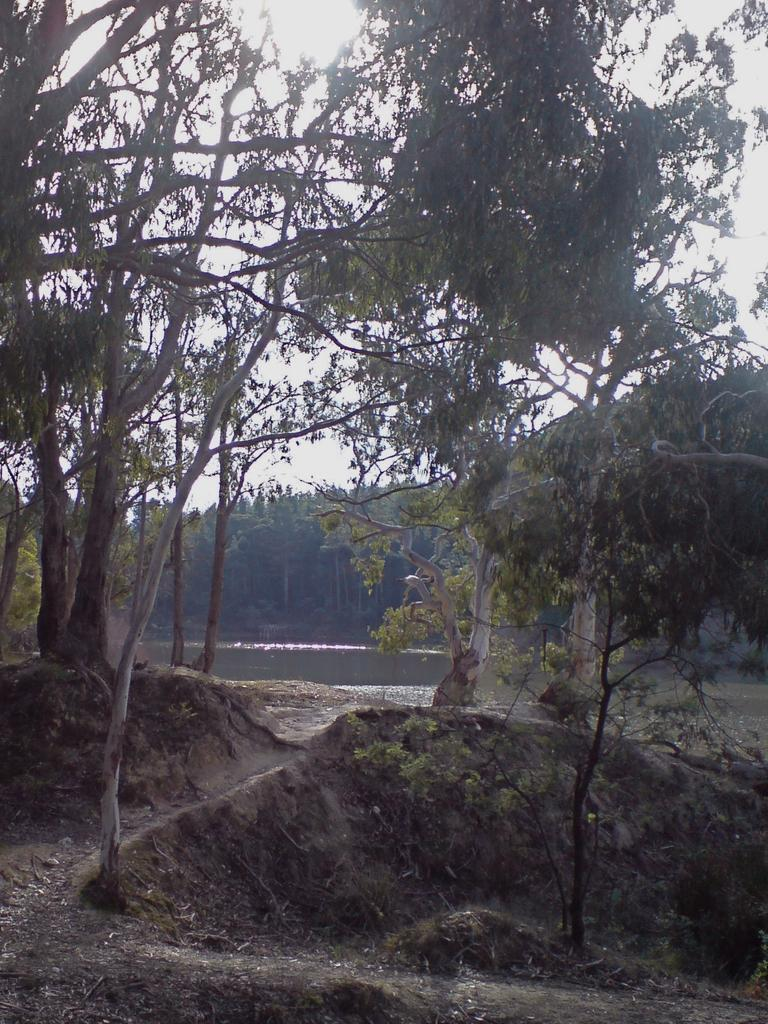What type of vegetation can be seen in the image? There are trees in the image. What body of water is present in the image? There is a lake in the center of the image. What part of the natural environment is visible in the image? The sky is visible in the background of the image. Where is the secretary sitting in the image? There is no secretary present in the image. What type of cork can be seen floating on the lake in the image? There is no cork visible in the image; it only features trees, a lake, and the sky. 